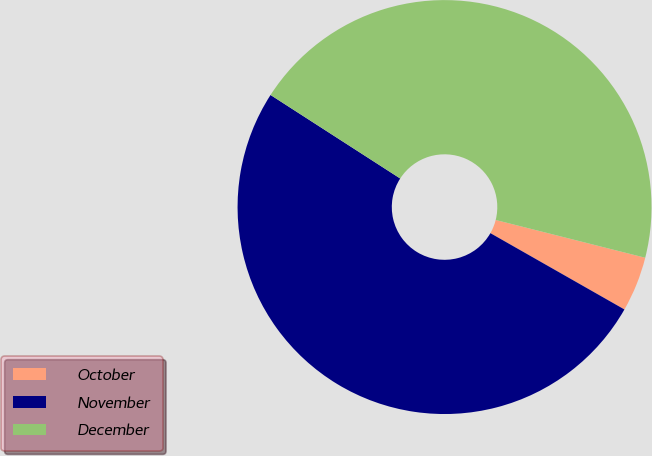Convert chart to OTSL. <chart><loc_0><loc_0><loc_500><loc_500><pie_chart><fcel>October<fcel>November<fcel>December<nl><fcel>4.3%<fcel>50.87%<fcel>44.83%<nl></chart> 